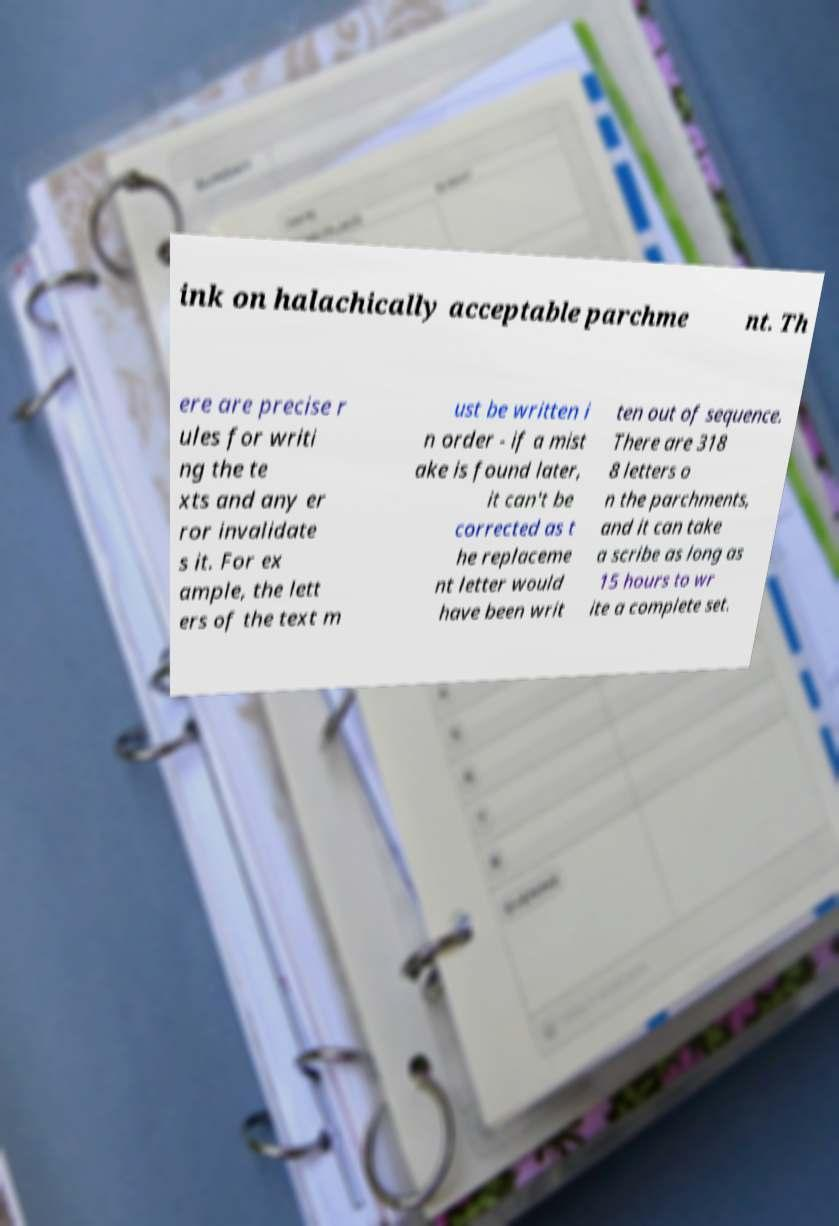Could you extract and type out the text from this image? ink on halachically acceptable parchme nt. Th ere are precise r ules for writi ng the te xts and any er ror invalidate s it. For ex ample, the lett ers of the text m ust be written i n order - if a mist ake is found later, it can't be corrected as t he replaceme nt letter would have been writ ten out of sequence. There are 318 8 letters o n the parchments, and it can take a scribe as long as 15 hours to wr ite a complete set. 